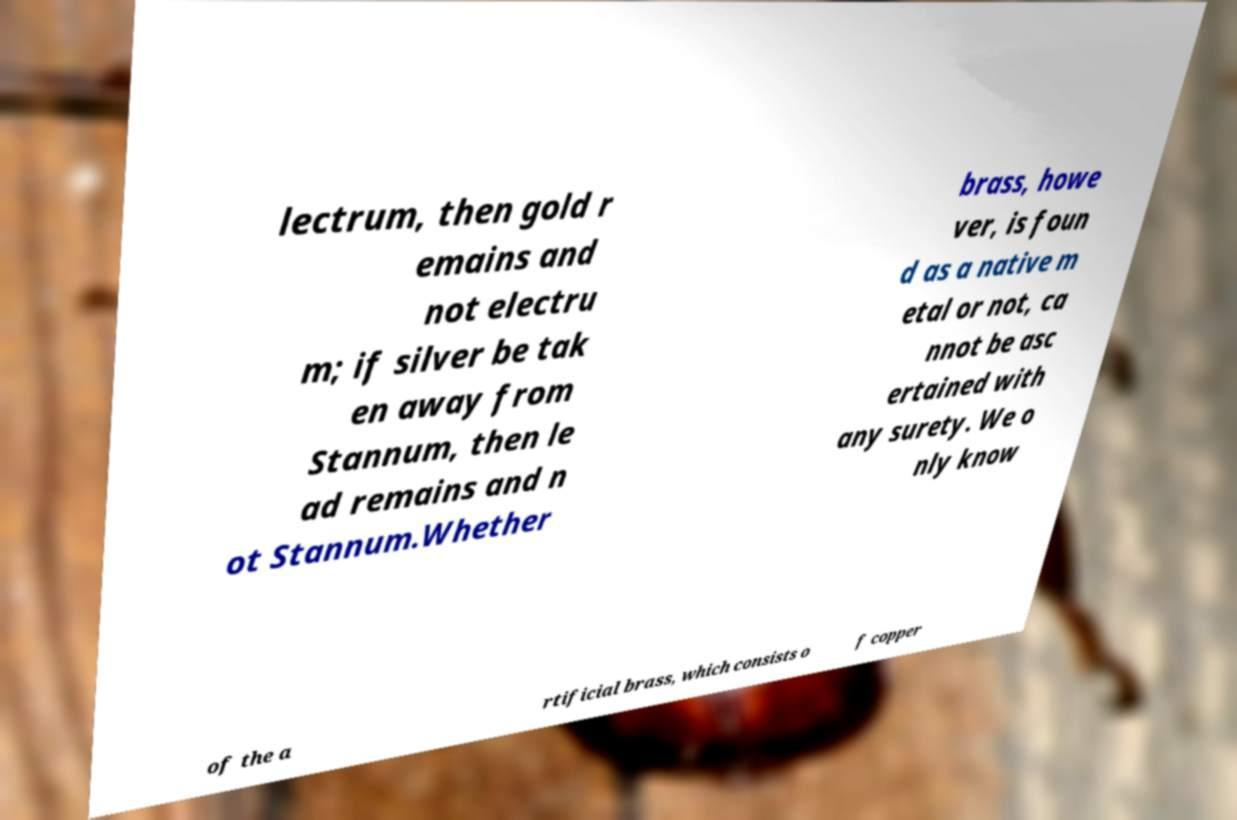Could you assist in decoding the text presented in this image and type it out clearly? lectrum, then gold r emains and not electru m; if silver be tak en away from Stannum, then le ad remains and n ot Stannum.Whether brass, howe ver, is foun d as a native m etal or not, ca nnot be asc ertained with any surety. We o nly know of the a rtificial brass, which consists o f copper 